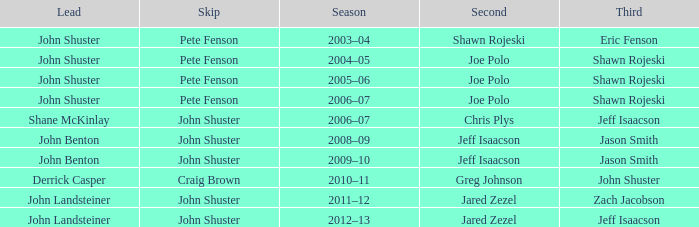Which season has Zach Jacobson in third? 2011–12. 